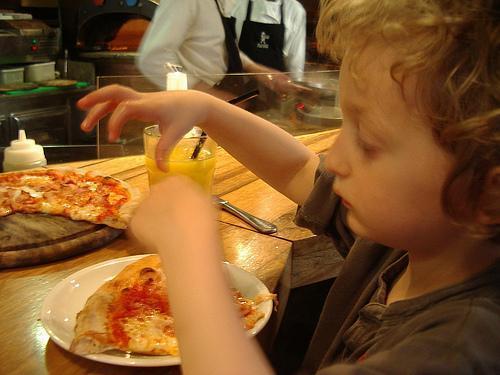How many children are there?
Give a very brief answer. 1. 